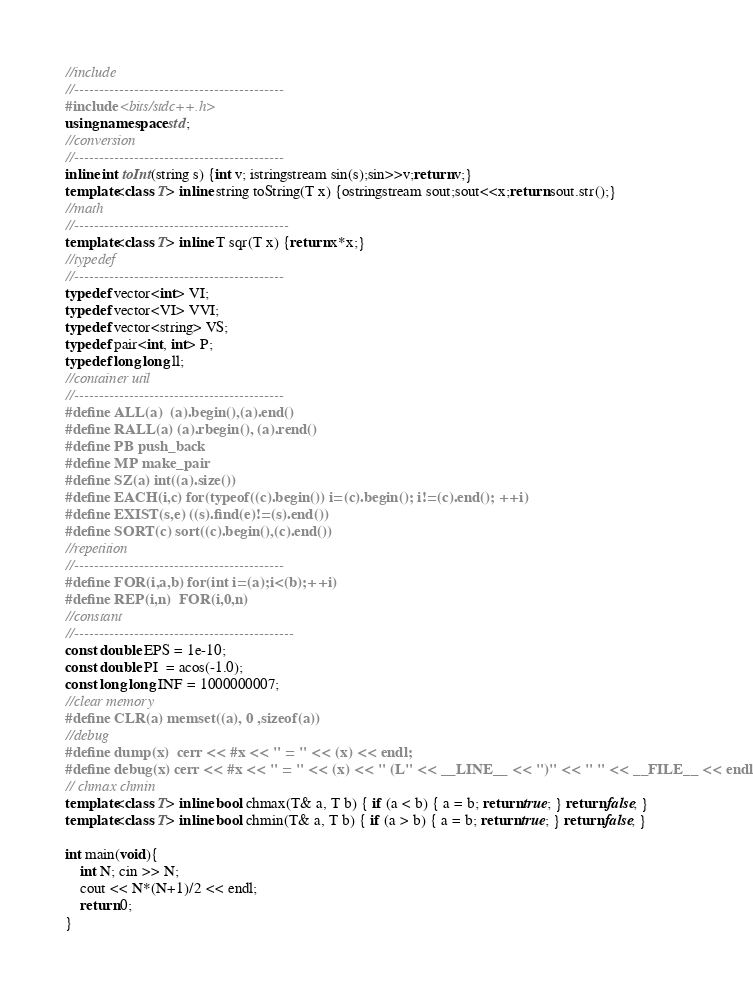<code> <loc_0><loc_0><loc_500><loc_500><_C++_>//include
//------------------------------------------
#include <bits/stdc++.h>
using namespace std;
//conversion
//------------------------------------------
inline int toInt(string s) {int v; istringstream sin(s);sin>>v;return v;}
template<class T> inline string toString(T x) {ostringstream sout;sout<<x;return sout.str();}
//math
//-------------------------------------------
template<class T> inline T sqr(T x) {return x*x;}
//typedef
//------------------------------------------
typedef vector<int> VI;
typedef vector<VI> VVI;
typedef vector<string> VS;
typedef pair<int, int> P;
typedef long long ll;
//container util
//------------------------------------------
#define ALL(a)  (a).begin(),(a).end()
#define RALL(a) (a).rbegin(), (a).rend()
#define PB push_back
#define MP make_pair
#define SZ(a) int((a).size())
#define EACH(i,c) for(typeof((c).begin()) i=(c).begin(); i!=(c).end(); ++i)
#define EXIST(s,e) ((s).find(e)!=(s).end())
#define SORT(c) sort((c).begin(),(c).end())
//repetition
//------------------------------------------
#define FOR(i,a,b) for(int i=(a);i<(b);++i)
#define REP(i,n)  FOR(i,0,n)
//constant
//--------------------------------------------
const double EPS = 1e-10;
const double PI  = acos(-1.0);
const long long INF = 1000000007;
//clear memory
#define CLR(a) memset((a), 0 ,sizeof(a))
//debug
#define dump(x)  cerr << #x << " = " << (x) << endl;
#define debug(x) cerr << #x << " = " << (x) << " (L" << __LINE__ << ")" << " " << __FILE__ << endl;
// chmax chmin
template<class T> inline bool chmax(T& a, T b) { if (a < b) { a = b; return true; } return false; }
template<class T> inline bool chmin(T& a, T b) { if (a > b) { a = b; return true; } return false; }

int main(void){
    int N; cin >> N;
    cout << N*(N+1)/2 << endl;
    return 0;
}</code> 